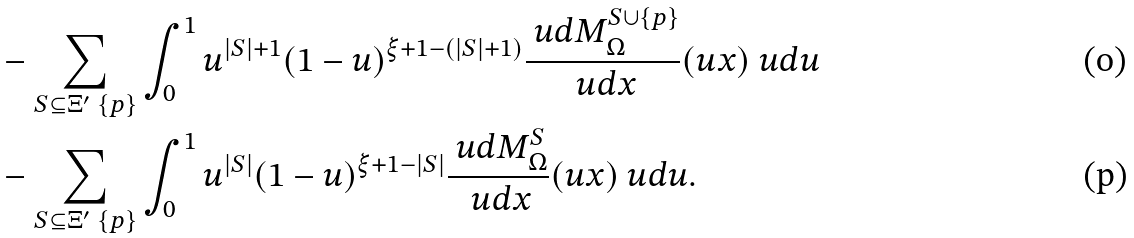<formula> <loc_0><loc_0><loc_500><loc_500>& - \sum _ { S \subseteq \Xi ^ { \prime } \ \{ p \} } \int _ { 0 } ^ { 1 } u ^ { | S | + 1 } ( 1 - u ) ^ { \xi + 1 - ( | S | + 1 ) } \frac { \ u d M _ { \Omega } ^ { S \cup \{ p \} } } { \ u d x } ( u x ) \ u d u \\ & - \sum _ { S \subseteq \Xi ^ { \prime } \ \{ p \} } \int _ { 0 } ^ { 1 } u ^ { | S | } ( 1 - u ) ^ { \xi + 1 - | S | } \frac { \ u d M _ { \Omega } ^ { S } } { \ u d x } ( u x ) \ u d u .</formula> 